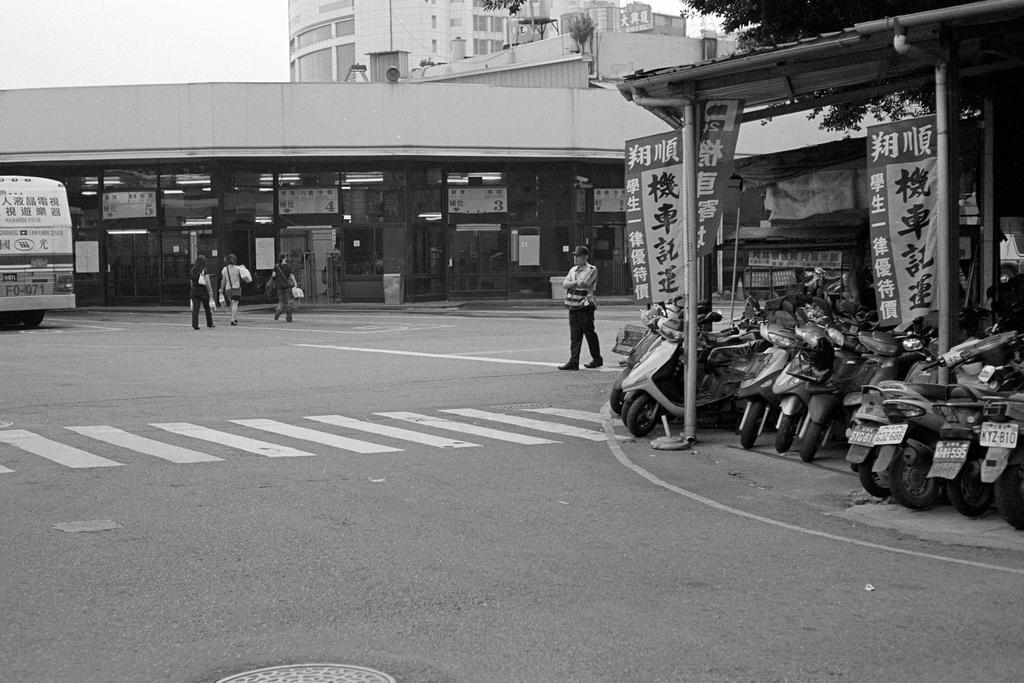Can you describe this image briefly? In this image I can see few people and vehicle on the road. To the right I can see the banners, tree and vehicles under the shed. In the background I can see the buildings, trees and the sky. 